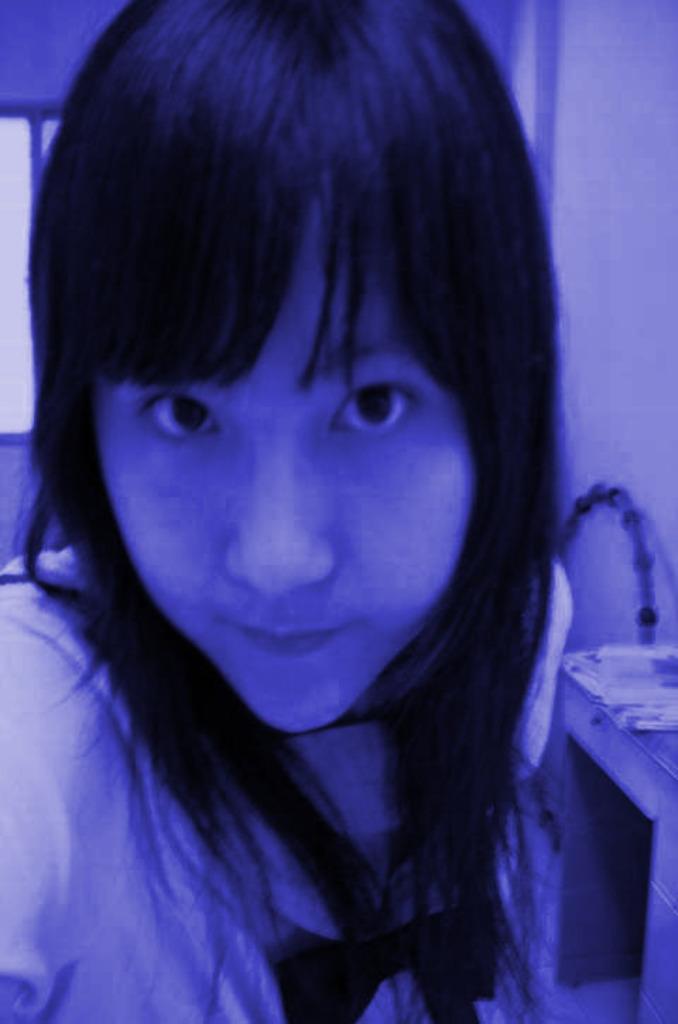Please provide a concise description of this image. In this picture I can see a woman and a table on the right side and I can see papers on it and I can see a ring on the right side and I can see a window on the back. 